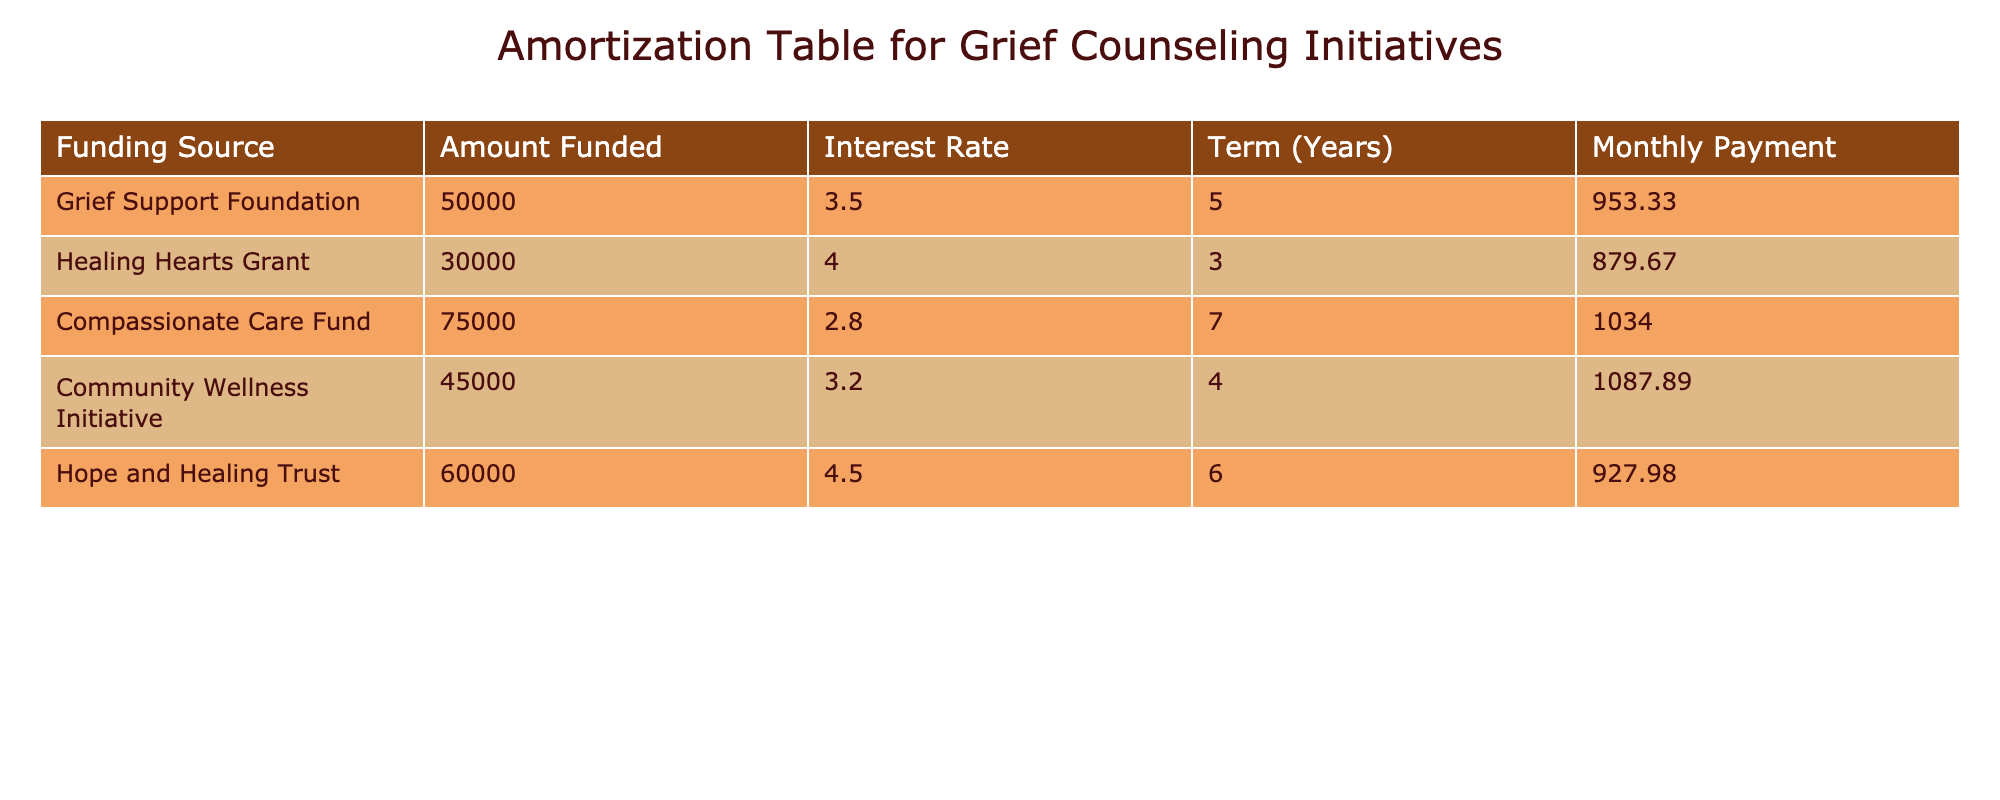What is the total amount funded across all sources? To find the total amount funded, I add the amounts from all sources: 50000 + 30000 + 75000 + 45000 + 60000 = 260000.
Answer: 260000 Which funding source has the highest monthly payment? Reviewing the "Monthly Payment" column, the highest value is 1087.89, which corresponds to the "Community Wellness Initiative."
Answer: Community Wellness Initiative Is the average interest rate of all the funding sources above 4%? First, I calculate the average interest rate: (3.5 + 4 + 2.8 + 3.2 + 4.5) / 5 = 3.8. Since 3.8 is less than 4, the answer is no.
Answer: No How much more is the "Compassionate Care Fund" payment compared to the "Healing Hearts Grant"? The monthly payment for "Compassionate Care Fund" is 1034.00 and for the "Healing Hearts Grant" it is 879.67. The difference is 1034.00 - 879.67 = 154.33.
Answer: 154.33 Which funding source has the lowest interest rate? Looking through the "Interest Rate" column, I see that the "Compassionate Care Fund" has the lowest rate of 2.8%.
Answer: Compassionate Care Fund What is the total monthly payment for all funding sources combined? I sum all the monthly payments: 953.33 + 879.67 + 1034.00 + 1087.89 + 927.98 = 4882.87.
Answer: 4882.87 Is it true that all funding sources have a term shorter than five years? The "Term" column shows that "Compassionate Care Fund" has a term of 7 years, which is greater than 5. Thus, the statement is false.
Answer: No Which funding source has a funded amount closest to 60000? By comparing the "Amount Funded" column, "Hope and Healing Trust" is the funding source that equals exactly 60000.
Answer: Hope and Healing Trust What is the median monthly payment for the funding sources? First, I list the monthly payments in increasing order: 879.67, 927.98, 953.33, 1034.00, 1087.89. The middle value (3rd value) is 953.33, which is the median.
Answer: 953.33 